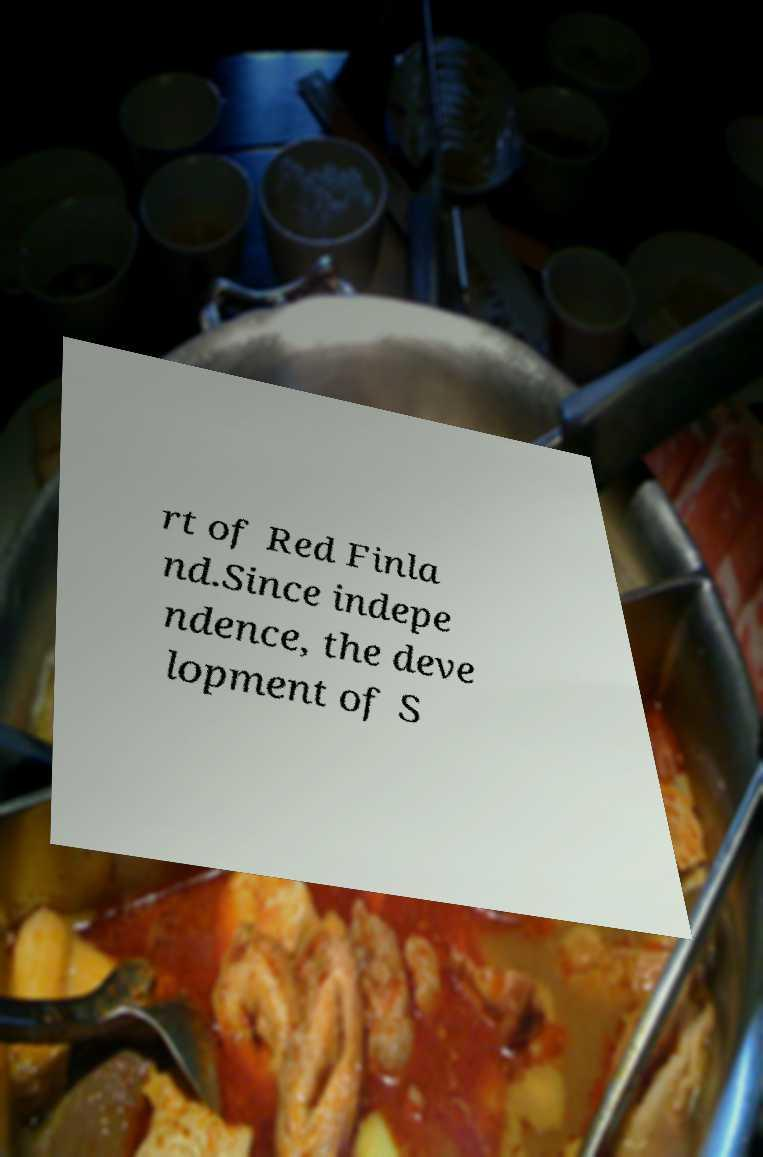Could you assist in decoding the text presented in this image and type it out clearly? rt of Red Finla nd.Since indepe ndence, the deve lopment of S 